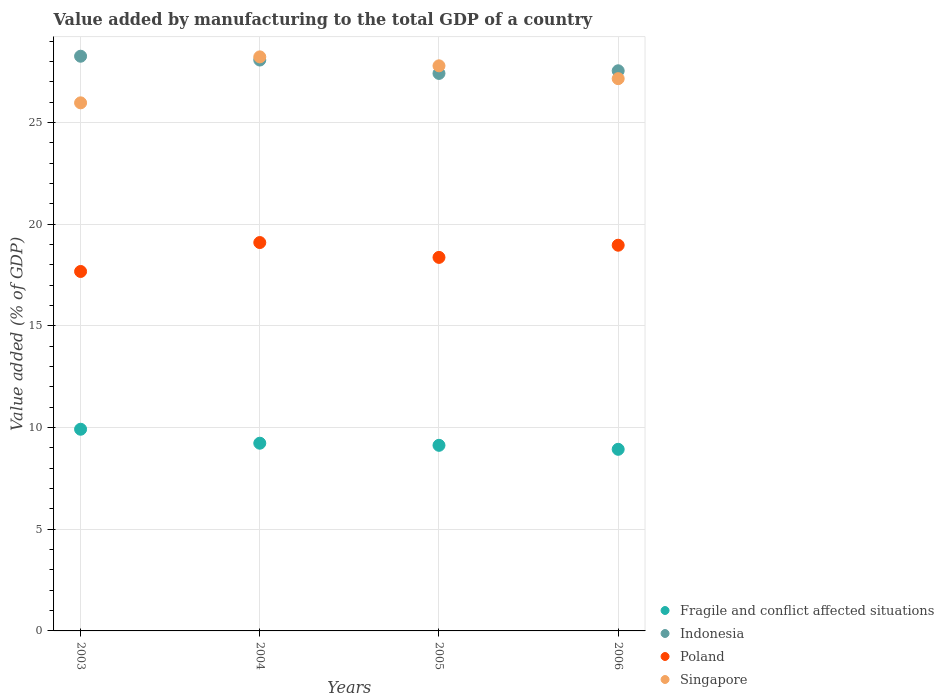How many different coloured dotlines are there?
Keep it short and to the point. 4. What is the value added by manufacturing to the total GDP in Singapore in 2004?
Offer a very short reply. 28.22. Across all years, what is the maximum value added by manufacturing to the total GDP in Poland?
Give a very brief answer. 19.09. Across all years, what is the minimum value added by manufacturing to the total GDP in Fragile and conflict affected situations?
Give a very brief answer. 8.93. In which year was the value added by manufacturing to the total GDP in Fragile and conflict affected situations maximum?
Keep it short and to the point. 2003. In which year was the value added by manufacturing to the total GDP in Fragile and conflict affected situations minimum?
Your answer should be very brief. 2006. What is the total value added by manufacturing to the total GDP in Singapore in the graph?
Your response must be concise. 109.11. What is the difference between the value added by manufacturing to the total GDP in Singapore in 2004 and that in 2005?
Provide a short and direct response. 0.44. What is the difference between the value added by manufacturing to the total GDP in Indonesia in 2006 and the value added by manufacturing to the total GDP in Poland in 2003?
Keep it short and to the point. 9.87. What is the average value added by manufacturing to the total GDP in Singapore per year?
Keep it short and to the point. 27.28. In the year 2005, what is the difference between the value added by manufacturing to the total GDP in Indonesia and value added by manufacturing to the total GDP in Poland?
Provide a short and direct response. 9.04. What is the ratio of the value added by manufacturing to the total GDP in Fragile and conflict affected situations in 2003 to that in 2006?
Provide a short and direct response. 1.11. Is the difference between the value added by manufacturing to the total GDP in Indonesia in 2004 and 2005 greater than the difference between the value added by manufacturing to the total GDP in Poland in 2004 and 2005?
Offer a very short reply. No. What is the difference between the highest and the second highest value added by manufacturing to the total GDP in Poland?
Provide a succinct answer. 0.13. What is the difference between the highest and the lowest value added by manufacturing to the total GDP in Singapore?
Provide a short and direct response. 2.26. In how many years, is the value added by manufacturing to the total GDP in Singapore greater than the average value added by manufacturing to the total GDP in Singapore taken over all years?
Your answer should be compact. 2. How many dotlines are there?
Provide a succinct answer. 4. How many years are there in the graph?
Offer a terse response. 4. Are the values on the major ticks of Y-axis written in scientific E-notation?
Offer a very short reply. No. Does the graph contain any zero values?
Offer a terse response. No. How many legend labels are there?
Make the answer very short. 4. How are the legend labels stacked?
Ensure brevity in your answer.  Vertical. What is the title of the graph?
Your answer should be compact. Value added by manufacturing to the total GDP of a country. Does "Ireland" appear as one of the legend labels in the graph?
Your answer should be compact. No. What is the label or title of the Y-axis?
Ensure brevity in your answer.  Value added (% of GDP). What is the Value added (% of GDP) in Fragile and conflict affected situations in 2003?
Your answer should be very brief. 9.92. What is the Value added (% of GDP) of Indonesia in 2003?
Provide a succinct answer. 28.25. What is the Value added (% of GDP) in Poland in 2003?
Your answer should be compact. 17.67. What is the Value added (% of GDP) in Singapore in 2003?
Offer a terse response. 25.96. What is the Value added (% of GDP) of Fragile and conflict affected situations in 2004?
Offer a terse response. 9.23. What is the Value added (% of GDP) in Indonesia in 2004?
Give a very brief answer. 28.07. What is the Value added (% of GDP) of Poland in 2004?
Offer a very short reply. 19.09. What is the Value added (% of GDP) of Singapore in 2004?
Your answer should be very brief. 28.22. What is the Value added (% of GDP) of Fragile and conflict affected situations in 2005?
Your response must be concise. 9.12. What is the Value added (% of GDP) of Indonesia in 2005?
Ensure brevity in your answer.  27.41. What is the Value added (% of GDP) of Poland in 2005?
Offer a terse response. 18.36. What is the Value added (% of GDP) of Singapore in 2005?
Your response must be concise. 27.78. What is the Value added (% of GDP) in Fragile and conflict affected situations in 2006?
Keep it short and to the point. 8.93. What is the Value added (% of GDP) of Indonesia in 2006?
Your answer should be compact. 27.54. What is the Value added (% of GDP) in Poland in 2006?
Give a very brief answer. 18.96. What is the Value added (% of GDP) in Singapore in 2006?
Your answer should be very brief. 27.15. Across all years, what is the maximum Value added (% of GDP) in Fragile and conflict affected situations?
Give a very brief answer. 9.92. Across all years, what is the maximum Value added (% of GDP) in Indonesia?
Offer a very short reply. 28.25. Across all years, what is the maximum Value added (% of GDP) in Poland?
Keep it short and to the point. 19.09. Across all years, what is the maximum Value added (% of GDP) of Singapore?
Make the answer very short. 28.22. Across all years, what is the minimum Value added (% of GDP) in Fragile and conflict affected situations?
Provide a succinct answer. 8.93. Across all years, what is the minimum Value added (% of GDP) in Indonesia?
Offer a terse response. 27.41. Across all years, what is the minimum Value added (% of GDP) in Poland?
Your answer should be compact. 17.67. Across all years, what is the minimum Value added (% of GDP) in Singapore?
Make the answer very short. 25.96. What is the total Value added (% of GDP) in Fragile and conflict affected situations in the graph?
Offer a terse response. 37.2. What is the total Value added (% of GDP) of Indonesia in the graph?
Offer a terse response. 111.26. What is the total Value added (% of GDP) in Poland in the graph?
Offer a very short reply. 74.09. What is the total Value added (% of GDP) in Singapore in the graph?
Your answer should be very brief. 109.11. What is the difference between the Value added (% of GDP) in Fragile and conflict affected situations in 2003 and that in 2004?
Ensure brevity in your answer.  0.69. What is the difference between the Value added (% of GDP) in Indonesia in 2003 and that in 2004?
Your response must be concise. 0.19. What is the difference between the Value added (% of GDP) in Poland in 2003 and that in 2004?
Offer a terse response. -1.42. What is the difference between the Value added (% of GDP) of Singapore in 2003 and that in 2004?
Give a very brief answer. -2.26. What is the difference between the Value added (% of GDP) in Fragile and conflict affected situations in 2003 and that in 2005?
Provide a short and direct response. 0.79. What is the difference between the Value added (% of GDP) in Indonesia in 2003 and that in 2005?
Make the answer very short. 0.85. What is the difference between the Value added (% of GDP) of Poland in 2003 and that in 2005?
Offer a terse response. -0.69. What is the difference between the Value added (% of GDP) in Singapore in 2003 and that in 2005?
Make the answer very short. -1.82. What is the difference between the Value added (% of GDP) of Indonesia in 2003 and that in 2006?
Your answer should be compact. 0.72. What is the difference between the Value added (% of GDP) of Poland in 2003 and that in 2006?
Give a very brief answer. -1.29. What is the difference between the Value added (% of GDP) in Singapore in 2003 and that in 2006?
Ensure brevity in your answer.  -1.19. What is the difference between the Value added (% of GDP) in Fragile and conflict affected situations in 2004 and that in 2005?
Keep it short and to the point. 0.1. What is the difference between the Value added (% of GDP) in Indonesia in 2004 and that in 2005?
Give a very brief answer. 0.66. What is the difference between the Value added (% of GDP) of Poland in 2004 and that in 2005?
Your response must be concise. 0.73. What is the difference between the Value added (% of GDP) of Singapore in 2004 and that in 2005?
Keep it short and to the point. 0.44. What is the difference between the Value added (% of GDP) in Fragile and conflict affected situations in 2004 and that in 2006?
Offer a terse response. 0.3. What is the difference between the Value added (% of GDP) in Indonesia in 2004 and that in 2006?
Keep it short and to the point. 0.53. What is the difference between the Value added (% of GDP) in Poland in 2004 and that in 2006?
Give a very brief answer. 0.13. What is the difference between the Value added (% of GDP) of Singapore in 2004 and that in 2006?
Offer a very short reply. 1.07. What is the difference between the Value added (% of GDP) in Fragile and conflict affected situations in 2005 and that in 2006?
Provide a succinct answer. 0.2. What is the difference between the Value added (% of GDP) in Indonesia in 2005 and that in 2006?
Your answer should be very brief. -0.13. What is the difference between the Value added (% of GDP) of Poland in 2005 and that in 2006?
Provide a short and direct response. -0.6. What is the difference between the Value added (% of GDP) in Singapore in 2005 and that in 2006?
Your answer should be very brief. 0.63. What is the difference between the Value added (% of GDP) in Fragile and conflict affected situations in 2003 and the Value added (% of GDP) in Indonesia in 2004?
Provide a short and direct response. -18.15. What is the difference between the Value added (% of GDP) of Fragile and conflict affected situations in 2003 and the Value added (% of GDP) of Poland in 2004?
Keep it short and to the point. -9.18. What is the difference between the Value added (% of GDP) in Fragile and conflict affected situations in 2003 and the Value added (% of GDP) in Singapore in 2004?
Make the answer very short. -18.31. What is the difference between the Value added (% of GDP) in Indonesia in 2003 and the Value added (% of GDP) in Poland in 2004?
Your response must be concise. 9.16. What is the difference between the Value added (% of GDP) of Indonesia in 2003 and the Value added (% of GDP) of Singapore in 2004?
Give a very brief answer. 0.03. What is the difference between the Value added (% of GDP) in Poland in 2003 and the Value added (% of GDP) in Singapore in 2004?
Keep it short and to the point. -10.55. What is the difference between the Value added (% of GDP) of Fragile and conflict affected situations in 2003 and the Value added (% of GDP) of Indonesia in 2005?
Make the answer very short. -17.49. What is the difference between the Value added (% of GDP) in Fragile and conflict affected situations in 2003 and the Value added (% of GDP) in Poland in 2005?
Offer a very short reply. -8.45. What is the difference between the Value added (% of GDP) in Fragile and conflict affected situations in 2003 and the Value added (% of GDP) in Singapore in 2005?
Provide a short and direct response. -17.87. What is the difference between the Value added (% of GDP) in Indonesia in 2003 and the Value added (% of GDP) in Poland in 2005?
Offer a terse response. 9.89. What is the difference between the Value added (% of GDP) in Indonesia in 2003 and the Value added (% of GDP) in Singapore in 2005?
Provide a succinct answer. 0.47. What is the difference between the Value added (% of GDP) in Poland in 2003 and the Value added (% of GDP) in Singapore in 2005?
Your answer should be compact. -10.11. What is the difference between the Value added (% of GDP) of Fragile and conflict affected situations in 2003 and the Value added (% of GDP) of Indonesia in 2006?
Give a very brief answer. -17.62. What is the difference between the Value added (% of GDP) of Fragile and conflict affected situations in 2003 and the Value added (% of GDP) of Poland in 2006?
Your answer should be compact. -9.05. What is the difference between the Value added (% of GDP) in Fragile and conflict affected situations in 2003 and the Value added (% of GDP) in Singapore in 2006?
Ensure brevity in your answer.  -17.23. What is the difference between the Value added (% of GDP) of Indonesia in 2003 and the Value added (% of GDP) of Poland in 2006?
Provide a short and direct response. 9.29. What is the difference between the Value added (% of GDP) in Indonesia in 2003 and the Value added (% of GDP) in Singapore in 2006?
Provide a short and direct response. 1.1. What is the difference between the Value added (% of GDP) of Poland in 2003 and the Value added (% of GDP) of Singapore in 2006?
Make the answer very short. -9.48. What is the difference between the Value added (% of GDP) in Fragile and conflict affected situations in 2004 and the Value added (% of GDP) in Indonesia in 2005?
Your answer should be very brief. -18.18. What is the difference between the Value added (% of GDP) of Fragile and conflict affected situations in 2004 and the Value added (% of GDP) of Poland in 2005?
Provide a succinct answer. -9.14. What is the difference between the Value added (% of GDP) in Fragile and conflict affected situations in 2004 and the Value added (% of GDP) in Singapore in 2005?
Offer a terse response. -18.55. What is the difference between the Value added (% of GDP) in Indonesia in 2004 and the Value added (% of GDP) in Poland in 2005?
Offer a very short reply. 9.7. What is the difference between the Value added (% of GDP) of Indonesia in 2004 and the Value added (% of GDP) of Singapore in 2005?
Keep it short and to the point. 0.28. What is the difference between the Value added (% of GDP) in Poland in 2004 and the Value added (% of GDP) in Singapore in 2005?
Offer a very short reply. -8.69. What is the difference between the Value added (% of GDP) of Fragile and conflict affected situations in 2004 and the Value added (% of GDP) of Indonesia in 2006?
Your answer should be very brief. -18.31. What is the difference between the Value added (% of GDP) of Fragile and conflict affected situations in 2004 and the Value added (% of GDP) of Poland in 2006?
Make the answer very short. -9.73. What is the difference between the Value added (% of GDP) of Fragile and conflict affected situations in 2004 and the Value added (% of GDP) of Singapore in 2006?
Keep it short and to the point. -17.92. What is the difference between the Value added (% of GDP) of Indonesia in 2004 and the Value added (% of GDP) of Poland in 2006?
Your answer should be compact. 9.1. What is the difference between the Value added (% of GDP) in Indonesia in 2004 and the Value added (% of GDP) in Singapore in 2006?
Make the answer very short. 0.92. What is the difference between the Value added (% of GDP) of Poland in 2004 and the Value added (% of GDP) of Singapore in 2006?
Provide a succinct answer. -8.06. What is the difference between the Value added (% of GDP) of Fragile and conflict affected situations in 2005 and the Value added (% of GDP) of Indonesia in 2006?
Provide a succinct answer. -18.41. What is the difference between the Value added (% of GDP) of Fragile and conflict affected situations in 2005 and the Value added (% of GDP) of Poland in 2006?
Offer a terse response. -9.84. What is the difference between the Value added (% of GDP) of Fragile and conflict affected situations in 2005 and the Value added (% of GDP) of Singapore in 2006?
Your response must be concise. -18.03. What is the difference between the Value added (% of GDP) in Indonesia in 2005 and the Value added (% of GDP) in Poland in 2006?
Your answer should be compact. 8.45. What is the difference between the Value added (% of GDP) in Indonesia in 2005 and the Value added (% of GDP) in Singapore in 2006?
Provide a succinct answer. 0.26. What is the difference between the Value added (% of GDP) in Poland in 2005 and the Value added (% of GDP) in Singapore in 2006?
Provide a succinct answer. -8.79. What is the average Value added (% of GDP) of Fragile and conflict affected situations per year?
Provide a succinct answer. 9.3. What is the average Value added (% of GDP) of Indonesia per year?
Ensure brevity in your answer.  27.82. What is the average Value added (% of GDP) of Poland per year?
Keep it short and to the point. 18.52. What is the average Value added (% of GDP) in Singapore per year?
Your answer should be compact. 27.28. In the year 2003, what is the difference between the Value added (% of GDP) of Fragile and conflict affected situations and Value added (% of GDP) of Indonesia?
Make the answer very short. -18.34. In the year 2003, what is the difference between the Value added (% of GDP) of Fragile and conflict affected situations and Value added (% of GDP) of Poland?
Make the answer very short. -7.76. In the year 2003, what is the difference between the Value added (% of GDP) of Fragile and conflict affected situations and Value added (% of GDP) of Singapore?
Provide a short and direct response. -16.05. In the year 2003, what is the difference between the Value added (% of GDP) in Indonesia and Value added (% of GDP) in Poland?
Provide a succinct answer. 10.58. In the year 2003, what is the difference between the Value added (% of GDP) of Indonesia and Value added (% of GDP) of Singapore?
Ensure brevity in your answer.  2.29. In the year 2003, what is the difference between the Value added (% of GDP) of Poland and Value added (% of GDP) of Singapore?
Offer a very short reply. -8.29. In the year 2004, what is the difference between the Value added (% of GDP) of Fragile and conflict affected situations and Value added (% of GDP) of Indonesia?
Your answer should be compact. -18.84. In the year 2004, what is the difference between the Value added (% of GDP) in Fragile and conflict affected situations and Value added (% of GDP) in Poland?
Provide a short and direct response. -9.87. In the year 2004, what is the difference between the Value added (% of GDP) of Fragile and conflict affected situations and Value added (% of GDP) of Singapore?
Your answer should be very brief. -18.99. In the year 2004, what is the difference between the Value added (% of GDP) in Indonesia and Value added (% of GDP) in Poland?
Ensure brevity in your answer.  8.97. In the year 2004, what is the difference between the Value added (% of GDP) of Indonesia and Value added (% of GDP) of Singapore?
Provide a short and direct response. -0.16. In the year 2004, what is the difference between the Value added (% of GDP) in Poland and Value added (% of GDP) in Singapore?
Offer a terse response. -9.13. In the year 2005, what is the difference between the Value added (% of GDP) of Fragile and conflict affected situations and Value added (% of GDP) of Indonesia?
Ensure brevity in your answer.  -18.28. In the year 2005, what is the difference between the Value added (% of GDP) of Fragile and conflict affected situations and Value added (% of GDP) of Poland?
Keep it short and to the point. -9.24. In the year 2005, what is the difference between the Value added (% of GDP) of Fragile and conflict affected situations and Value added (% of GDP) of Singapore?
Offer a terse response. -18.66. In the year 2005, what is the difference between the Value added (% of GDP) of Indonesia and Value added (% of GDP) of Poland?
Offer a very short reply. 9.04. In the year 2005, what is the difference between the Value added (% of GDP) of Indonesia and Value added (% of GDP) of Singapore?
Provide a short and direct response. -0.37. In the year 2005, what is the difference between the Value added (% of GDP) of Poland and Value added (% of GDP) of Singapore?
Provide a short and direct response. -9.42. In the year 2006, what is the difference between the Value added (% of GDP) in Fragile and conflict affected situations and Value added (% of GDP) in Indonesia?
Ensure brevity in your answer.  -18.61. In the year 2006, what is the difference between the Value added (% of GDP) of Fragile and conflict affected situations and Value added (% of GDP) of Poland?
Your answer should be very brief. -10.03. In the year 2006, what is the difference between the Value added (% of GDP) of Fragile and conflict affected situations and Value added (% of GDP) of Singapore?
Give a very brief answer. -18.22. In the year 2006, what is the difference between the Value added (% of GDP) in Indonesia and Value added (% of GDP) in Poland?
Your answer should be compact. 8.58. In the year 2006, what is the difference between the Value added (% of GDP) of Indonesia and Value added (% of GDP) of Singapore?
Offer a terse response. 0.39. In the year 2006, what is the difference between the Value added (% of GDP) of Poland and Value added (% of GDP) of Singapore?
Your answer should be compact. -8.19. What is the ratio of the Value added (% of GDP) of Fragile and conflict affected situations in 2003 to that in 2004?
Provide a short and direct response. 1.07. What is the ratio of the Value added (% of GDP) in Indonesia in 2003 to that in 2004?
Ensure brevity in your answer.  1.01. What is the ratio of the Value added (% of GDP) of Poland in 2003 to that in 2004?
Your answer should be compact. 0.93. What is the ratio of the Value added (% of GDP) of Singapore in 2003 to that in 2004?
Offer a terse response. 0.92. What is the ratio of the Value added (% of GDP) in Fragile and conflict affected situations in 2003 to that in 2005?
Ensure brevity in your answer.  1.09. What is the ratio of the Value added (% of GDP) in Indonesia in 2003 to that in 2005?
Your response must be concise. 1.03. What is the ratio of the Value added (% of GDP) of Poland in 2003 to that in 2005?
Keep it short and to the point. 0.96. What is the ratio of the Value added (% of GDP) in Singapore in 2003 to that in 2005?
Your response must be concise. 0.93. What is the ratio of the Value added (% of GDP) of Fragile and conflict affected situations in 2003 to that in 2006?
Provide a short and direct response. 1.11. What is the ratio of the Value added (% of GDP) of Indonesia in 2003 to that in 2006?
Your answer should be very brief. 1.03. What is the ratio of the Value added (% of GDP) of Poland in 2003 to that in 2006?
Offer a terse response. 0.93. What is the ratio of the Value added (% of GDP) of Singapore in 2003 to that in 2006?
Offer a terse response. 0.96. What is the ratio of the Value added (% of GDP) of Fragile and conflict affected situations in 2004 to that in 2005?
Give a very brief answer. 1.01. What is the ratio of the Value added (% of GDP) in Indonesia in 2004 to that in 2005?
Your response must be concise. 1.02. What is the ratio of the Value added (% of GDP) of Poland in 2004 to that in 2005?
Your answer should be very brief. 1.04. What is the ratio of the Value added (% of GDP) of Singapore in 2004 to that in 2005?
Offer a terse response. 1.02. What is the ratio of the Value added (% of GDP) in Fragile and conflict affected situations in 2004 to that in 2006?
Provide a short and direct response. 1.03. What is the ratio of the Value added (% of GDP) of Indonesia in 2004 to that in 2006?
Provide a short and direct response. 1.02. What is the ratio of the Value added (% of GDP) in Poland in 2004 to that in 2006?
Give a very brief answer. 1.01. What is the ratio of the Value added (% of GDP) in Singapore in 2004 to that in 2006?
Your response must be concise. 1.04. What is the ratio of the Value added (% of GDP) in Poland in 2005 to that in 2006?
Make the answer very short. 0.97. What is the ratio of the Value added (% of GDP) in Singapore in 2005 to that in 2006?
Keep it short and to the point. 1.02. What is the difference between the highest and the second highest Value added (% of GDP) of Fragile and conflict affected situations?
Provide a succinct answer. 0.69. What is the difference between the highest and the second highest Value added (% of GDP) in Indonesia?
Provide a short and direct response. 0.19. What is the difference between the highest and the second highest Value added (% of GDP) of Poland?
Offer a terse response. 0.13. What is the difference between the highest and the second highest Value added (% of GDP) of Singapore?
Make the answer very short. 0.44. What is the difference between the highest and the lowest Value added (% of GDP) in Indonesia?
Provide a short and direct response. 0.85. What is the difference between the highest and the lowest Value added (% of GDP) of Poland?
Offer a terse response. 1.42. What is the difference between the highest and the lowest Value added (% of GDP) in Singapore?
Offer a very short reply. 2.26. 